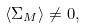<formula> <loc_0><loc_0><loc_500><loc_500>\langle \Sigma _ { M } \rangle \neq 0 ,</formula> 